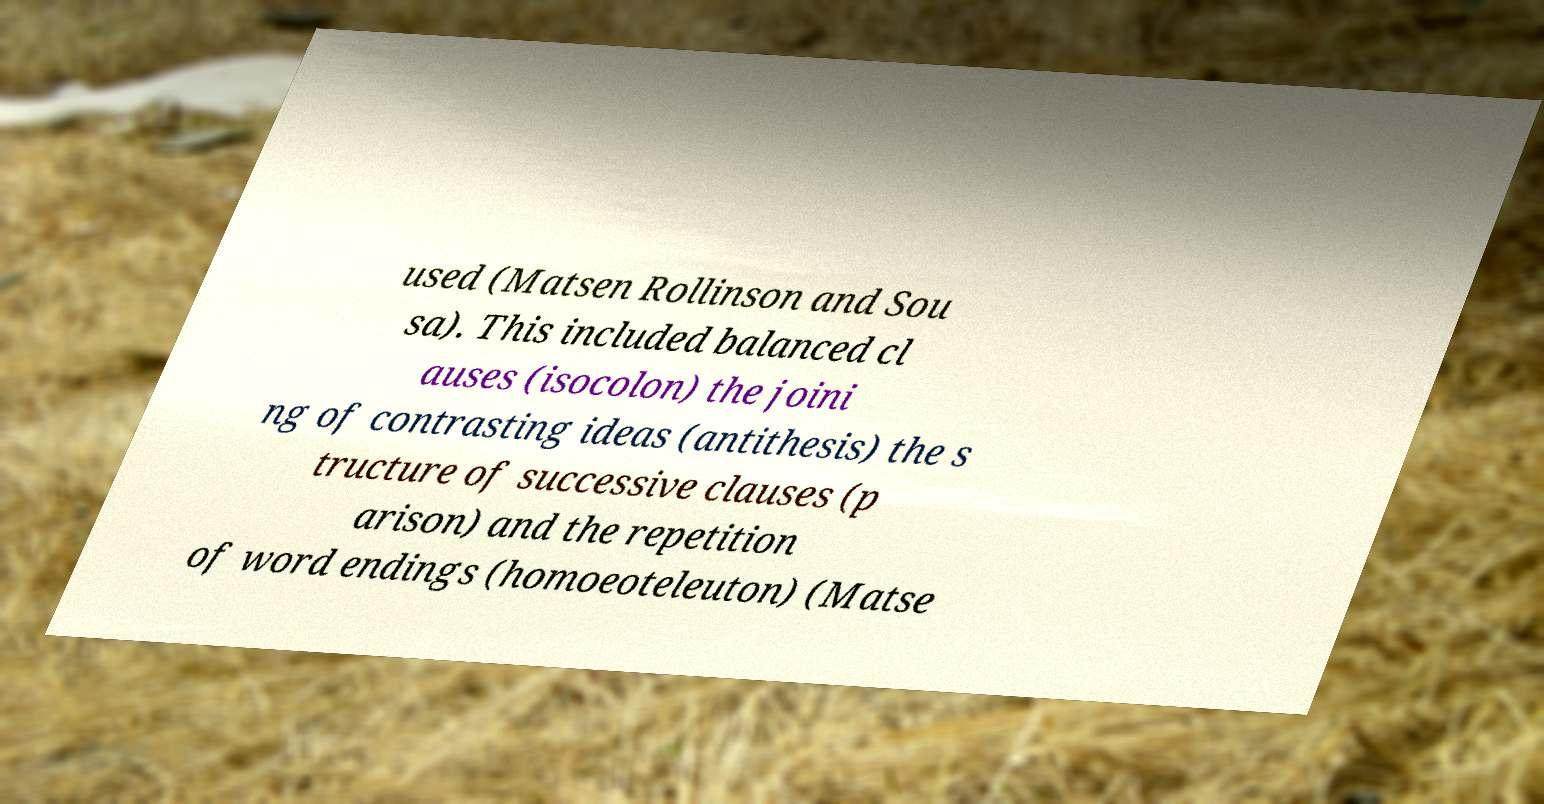Could you extract and type out the text from this image? used (Matsen Rollinson and Sou sa). This included balanced cl auses (isocolon) the joini ng of contrasting ideas (antithesis) the s tructure of successive clauses (p arison) and the repetition of word endings (homoeoteleuton) (Matse 